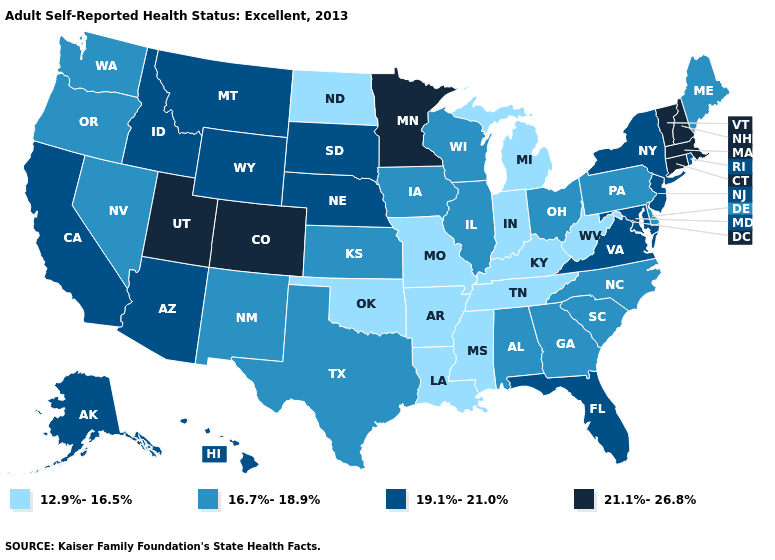Does Washington have a lower value than Missouri?
Short answer required. No. What is the value of Maryland?
Keep it brief. 19.1%-21.0%. Name the states that have a value in the range 12.9%-16.5%?
Give a very brief answer. Arkansas, Indiana, Kentucky, Louisiana, Michigan, Mississippi, Missouri, North Dakota, Oklahoma, Tennessee, West Virginia. Which states have the highest value in the USA?
Be succinct. Colorado, Connecticut, Massachusetts, Minnesota, New Hampshire, Utah, Vermont. What is the lowest value in states that border Kentucky?
Be succinct. 12.9%-16.5%. Which states have the lowest value in the Northeast?
Concise answer only. Maine, Pennsylvania. Which states hav the highest value in the West?
Short answer required. Colorado, Utah. Name the states that have a value in the range 12.9%-16.5%?
Short answer required. Arkansas, Indiana, Kentucky, Louisiana, Michigan, Mississippi, Missouri, North Dakota, Oklahoma, Tennessee, West Virginia. Name the states that have a value in the range 21.1%-26.8%?
Answer briefly. Colorado, Connecticut, Massachusetts, Minnesota, New Hampshire, Utah, Vermont. Does Utah have the lowest value in the West?
Answer briefly. No. What is the highest value in the USA?
Give a very brief answer. 21.1%-26.8%. Name the states that have a value in the range 12.9%-16.5%?
Quick response, please. Arkansas, Indiana, Kentucky, Louisiana, Michigan, Mississippi, Missouri, North Dakota, Oklahoma, Tennessee, West Virginia. Name the states that have a value in the range 21.1%-26.8%?
Give a very brief answer. Colorado, Connecticut, Massachusetts, Minnesota, New Hampshire, Utah, Vermont. Among the states that border South Dakota , which have the lowest value?
Short answer required. North Dakota. Name the states that have a value in the range 12.9%-16.5%?
Be succinct. Arkansas, Indiana, Kentucky, Louisiana, Michigan, Mississippi, Missouri, North Dakota, Oklahoma, Tennessee, West Virginia. 